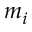Convert formula to latex. <formula><loc_0><loc_0><loc_500><loc_500>m _ { i }</formula> 